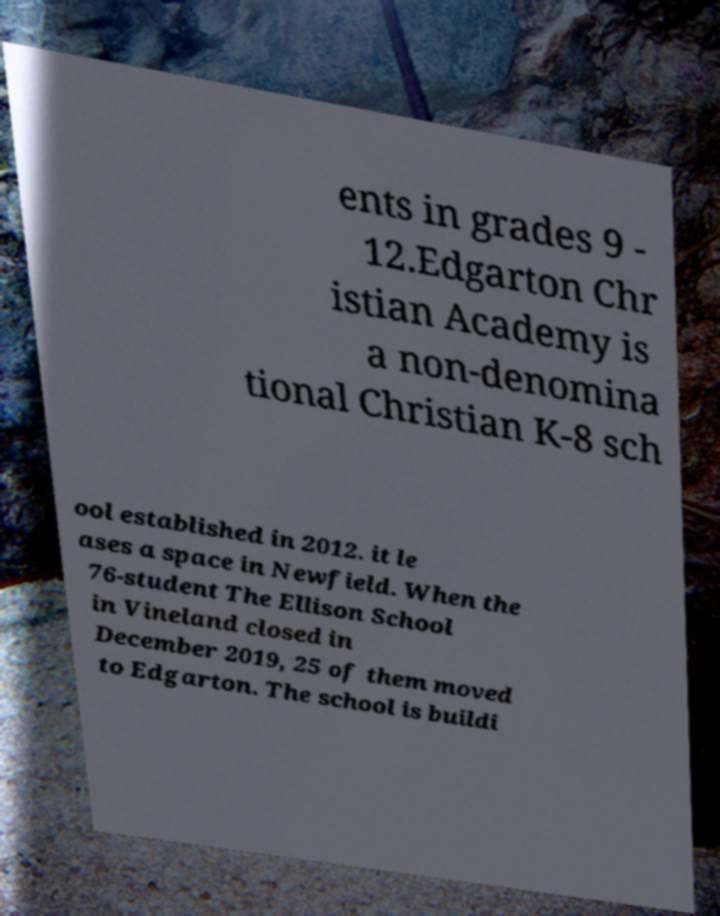Please identify and transcribe the text found in this image. ents in grades 9 - 12.Edgarton Chr istian Academy is a non-denomina tional Christian K-8 sch ool established in 2012. it le ases a space in Newfield. When the 76-student The Ellison School in Vineland closed in December 2019, 25 of them moved to Edgarton. The school is buildi 